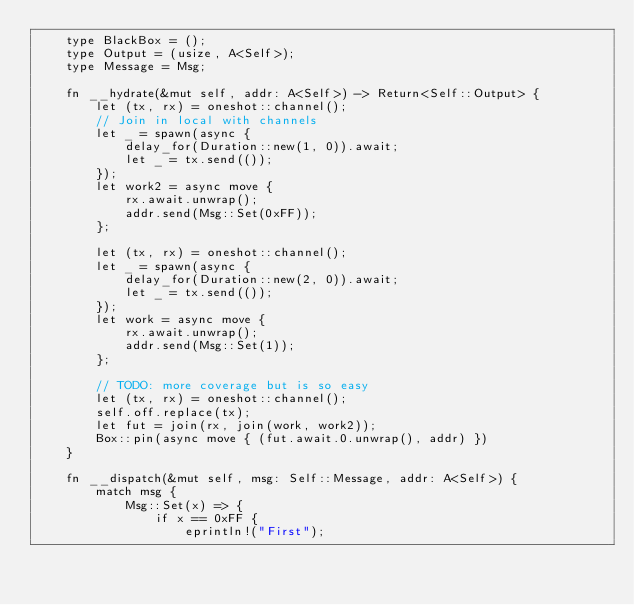Convert code to text. <code><loc_0><loc_0><loc_500><loc_500><_Rust_>    type BlackBox = ();
    type Output = (usize, A<Self>);
    type Message = Msg;

    fn __hydrate(&mut self, addr: A<Self>) -> Return<Self::Output> {
        let (tx, rx) = oneshot::channel();
        // Join in local with channels
        let _ = spawn(async {
            delay_for(Duration::new(1, 0)).await;
            let _ = tx.send(());
        });
        let work2 = async move {
            rx.await.unwrap();
            addr.send(Msg::Set(0xFF));
        };

        let (tx, rx) = oneshot::channel();
        let _ = spawn(async {
            delay_for(Duration::new(2, 0)).await;
            let _ = tx.send(());
        });
        let work = async move {
            rx.await.unwrap();
            addr.send(Msg::Set(1));
        };

        // TODO: more coverage but is so easy
        let (tx, rx) = oneshot::channel();
        self.off.replace(tx);
        let fut = join(rx, join(work, work2));
        Box::pin(async move { (fut.await.0.unwrap(), addr) })
    }

    fn __dispatch(&mut self, msg: Self::Message, addr: A<Self>) {
        match msg {
            Msg::Set(x) => {
                if x == 0xFF {
                    eprintln!("First");</code> 